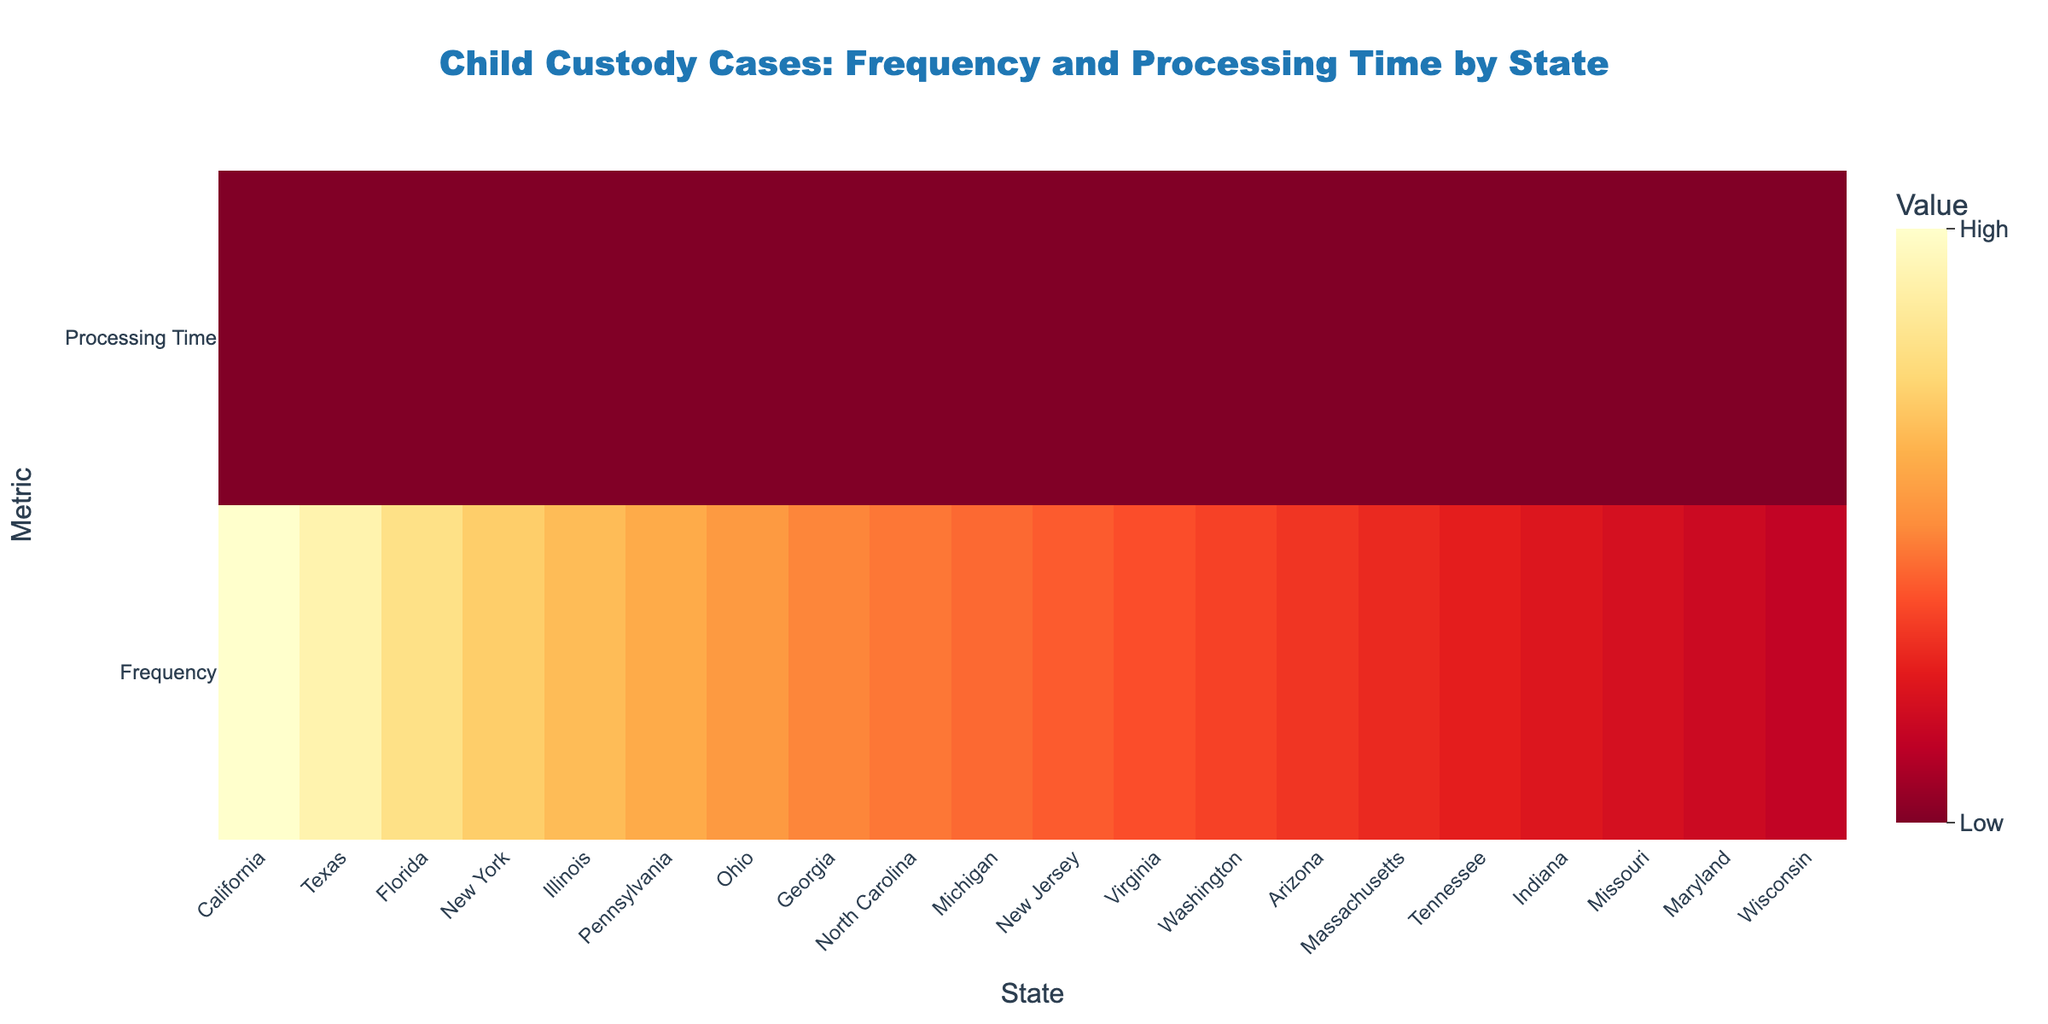What is the title of the heatmap? The title is located at the top of the heatmap, and it specifies the subject and context of the data being visualized.
Answer: Child Custody Cases: Frequency and Processing Time by State How many data points are shown for each state? Each state has two data points represented in the heatmap: "Frequency of Favorable Court Decisions for Custody Cases per Year" and "Processing Time in Months". This can be observed from the y-axis labels.
Answer: 2 Which state has the highest frequency of favorable court decisions for child custody cases? By examining the color intensity on the heatmap, the state with the highest frequency can be identified. The legend indicates that a brighter color represents a higher frequency.
Answer: California Which state has the longest processing time for child custody cases? Similar to finding the highest frequency, the longest processing time can be identified by looking for the state with the most intense color in the "Processing Time" row.
Answer: Illinois What is the average processing time for child custody cases across all states? To find the average processing time, add up the processing times for all the states (8+7+6+9+10+8+7+6+5+8+9+7+6+5+8+7+6+8+7+6 = 143) and divide by the number of states (20).
Answer: 7.15 months Which state has both below-average frequency and below-average processing time? Identify states with both metrics falling below their respective averages. The mean frequency is (sum of frequencies / number of states); in this case, mean frequency is (3500+3200+2800+2500+2300+2100+1900+1700+1600+1500+1400+1300+1200+1100+1000+900+800+700+600+500 = 35100 / 20 = 1755). Also, the average processing time is 7.15 months. States with values below both averages are considered here.
Answer: Arizona Which state has a lower processing time but a higher frequency of favorable court decisions compared to Illinois? First, note Illinois' figures (2300 and 10 months). Then look for states with a processing time less than 10 months but a frequency higher than 2300 in the heatmap.
Answer: California, Texas, Florida, New York Is there a state with similar processing times but significantly different frequencies of court decisions? Compare states with close processing times and different decision frequencies by observing color similarities and differences. "Similar processing time" could mean within 1 month difference.
Answer: New York and New Jersey (both have 9 months but different frequencies) What is the difference between the highest and lowest frequencies of favorable court decisions? The highest frequency is 3500 (California) and the lowest is 500 (Wisconsin). Subtract the lowest from the highest to get the difference.
Answer: 3000 